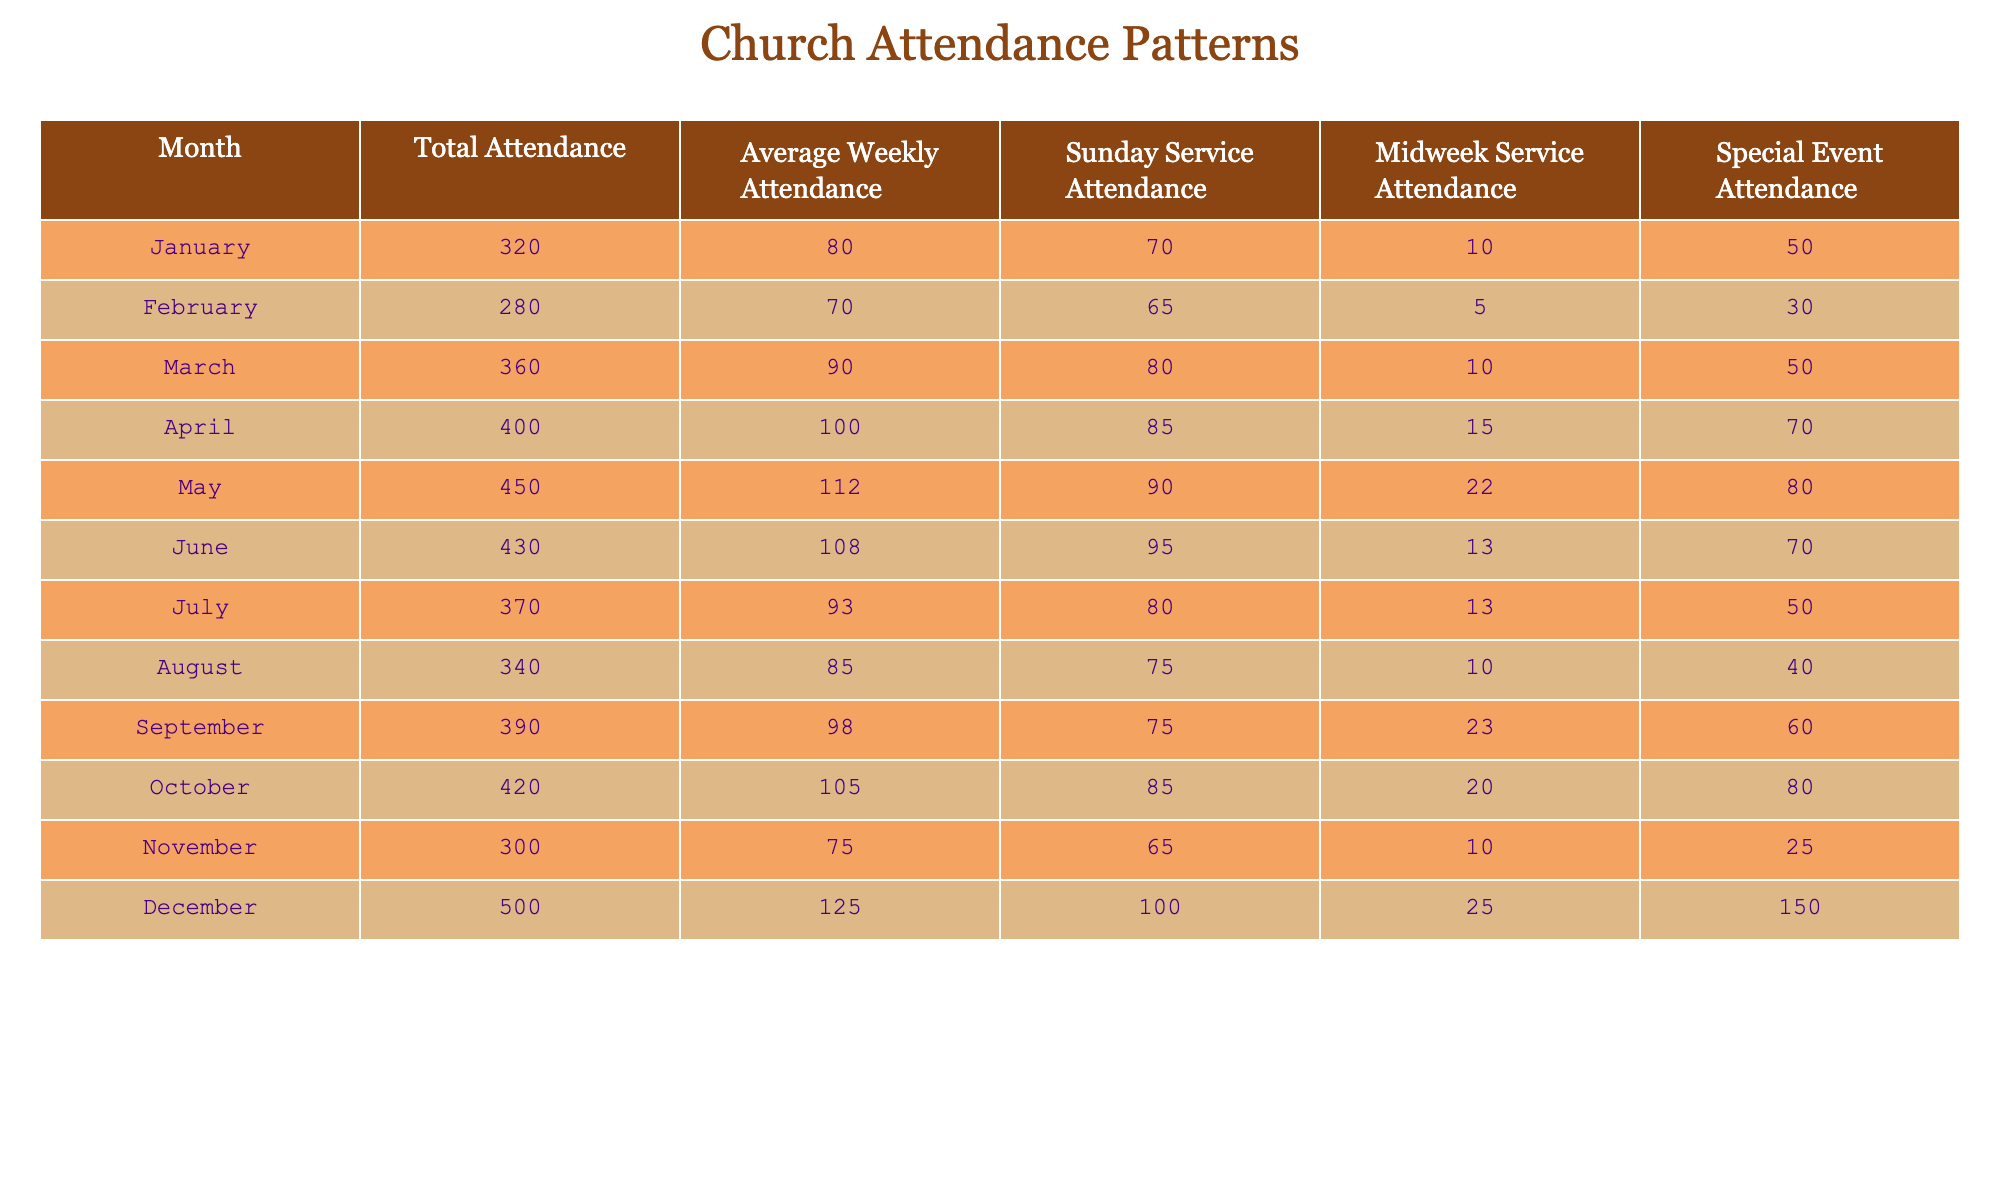What was the total attendance in December? The table shows that for the month of December, the "Total Attendance" column lists the value 500. This value is specific to December, so it can be directly retrieved from the table.
Answer: 500 What was the average weekly attendance in June? Looking at the "Average Weekly Attendance" column, June has a value of 108. This is the information needed for the answer, which is directly available in the table.
Answer: 108 In which month was the Sunday Service attendance the highest, and what was that attendance? Observing the "Sunday Service Attendance" column, the maximum value occurs in December with a figure of 100. Therefore, December has the highest Sunday Service attendance.
Answer: December, 100 What was the total attendance from January to March? To find the total attendance for these months, we need to sum the values for January (320), February (280), and March (360). The calculation is 320 + 280 + 360 = 960, so the total is 960.
Answer: 960 Is the average weekly attendance in October greater than 100? The value for average weekly attendance in October is 105. Since 105 is greater than 100, the answer to the question is yes.
Answer: Yes What is the difference in total attendance between April and November? First, we find the total attendance for April, which is 400, and for November, which is 300. Now we calculate the difference: 400 - 300 = 100. Thus, the difference in total attendance is 100.
Answer: 100 How many more people attended special events in December compared to February? For December, the special event attendance is 150, and for February, it is 30. The difference is calculated as 150 - 30 = 120, meaning more attendees in December compared to February.
Answer: 120 What is the average Sunday Service attendance over the year? To find the average, we first sum the Sunday Service attendance for all months: (70 + 65 + 80 + 85 + 90 + 95 + 80 + 75 + 75 + 85 + 65 + 100) = 1000. There are 12 months, so we divide: 1000 / 12 = 83.33, which rounds to 83 when considering whole people.
Answer: 83 Which month had the lowest total attendance, and what was that attendance? The month with the lowest total attendance can be identified by comparing all the values in the "Total Attendance" column. The lowest is February with an attendance of 280.
Answer: February, 280 